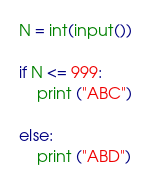Convert code to text. <code><loc_0><loc_0><loc_500><loc_500><_Python_>N = int(input())

if N <= 999:
    print ("ABC")

else:
    print ("ABD")</code> 